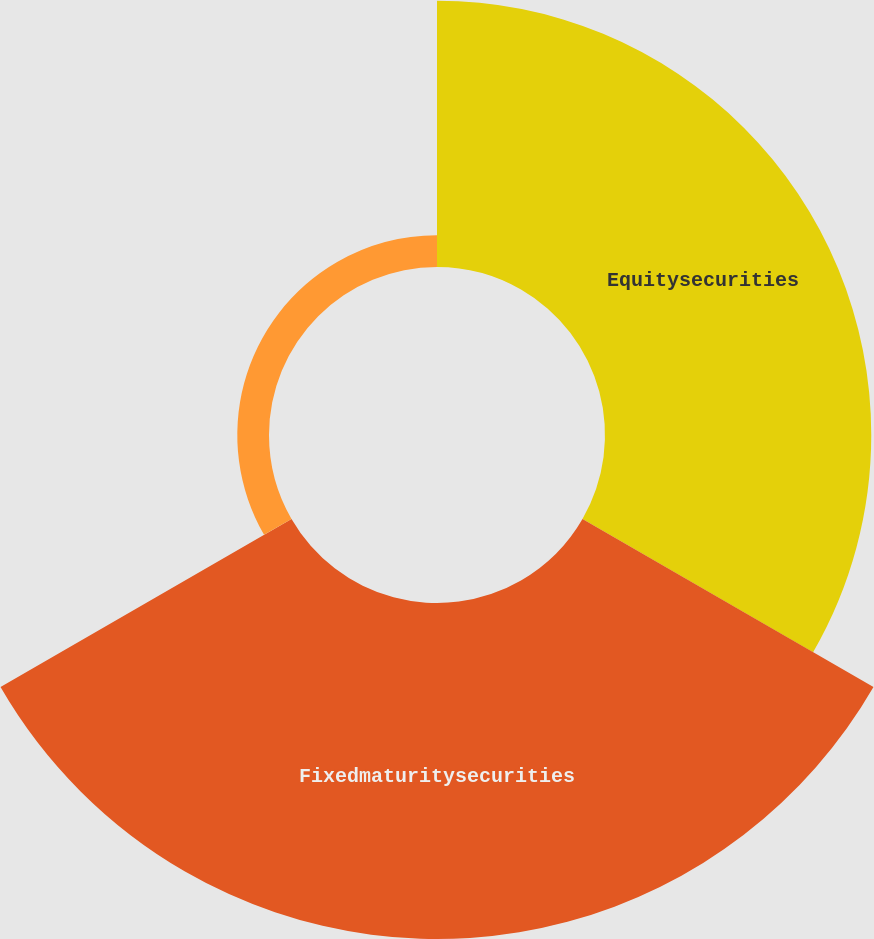<chart> <loc_0><loc_0><loc_500><loc_500><pie_chart><fcel>Equitysecurities<fcel>Fixedmaturitysecurities<fcel>Unnamed: 2<nl><fcel>42.0%<fcel>53.0%<fcel>5.0%<nl></chart> 